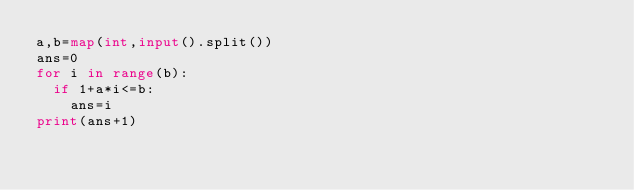<code> <loc_0><loc_0><loc_500><loc_500><_Python_>a,b=map(int,input().split())
ans=0
for i in range(b):
  if 1+a*i<=b:
    ans=i
print(ans+1)</code> 